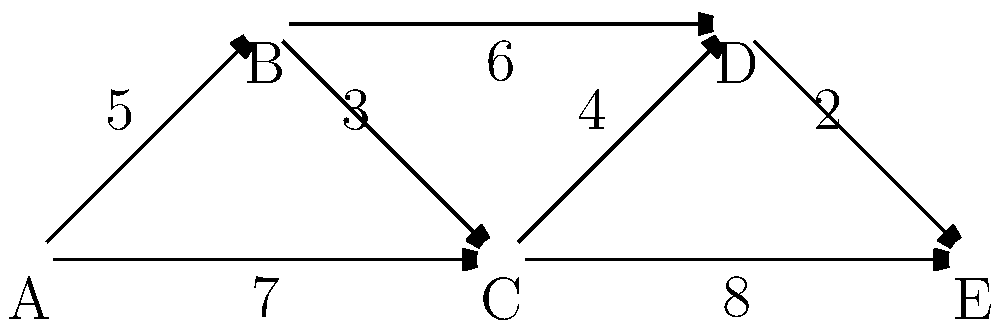In the network diagram representing data flow between interconnected surveillance systems, what is the minimum number of systems the data must pass through to reach system E from system A, and what is the total data transfer volume for this path? To solve this problem, we need to follow these steps:

1. Identify all possible paths from A to E:
   - Path 1: A → B → C → D → E
   - Path 2: A → B → D → E
   - Path 3: A → C → D → E
   - Path 4: A → C → E

2. Count the number of systems (nodes) in each path:
   - Path 1: 5 systems
   - Path 2: 4 systems
   - Path 3: 4 systems
   - Path 4: 3 systems

3. Identify the path(s) with the minimum number of systems:
   Path 4 (A → C → E) has the minimum number of systems (3).

4. Calculate the total data transfer volume for the minimum path:
   A → C: 7 units
   C → E: 8 units
   Total: 7 + 8 = 15 units

Therefore, the minimum number of systems the data must pass through is 3, and the total data transfer volume for this path is 15 units.
Answer: 3 systems, 15 units 